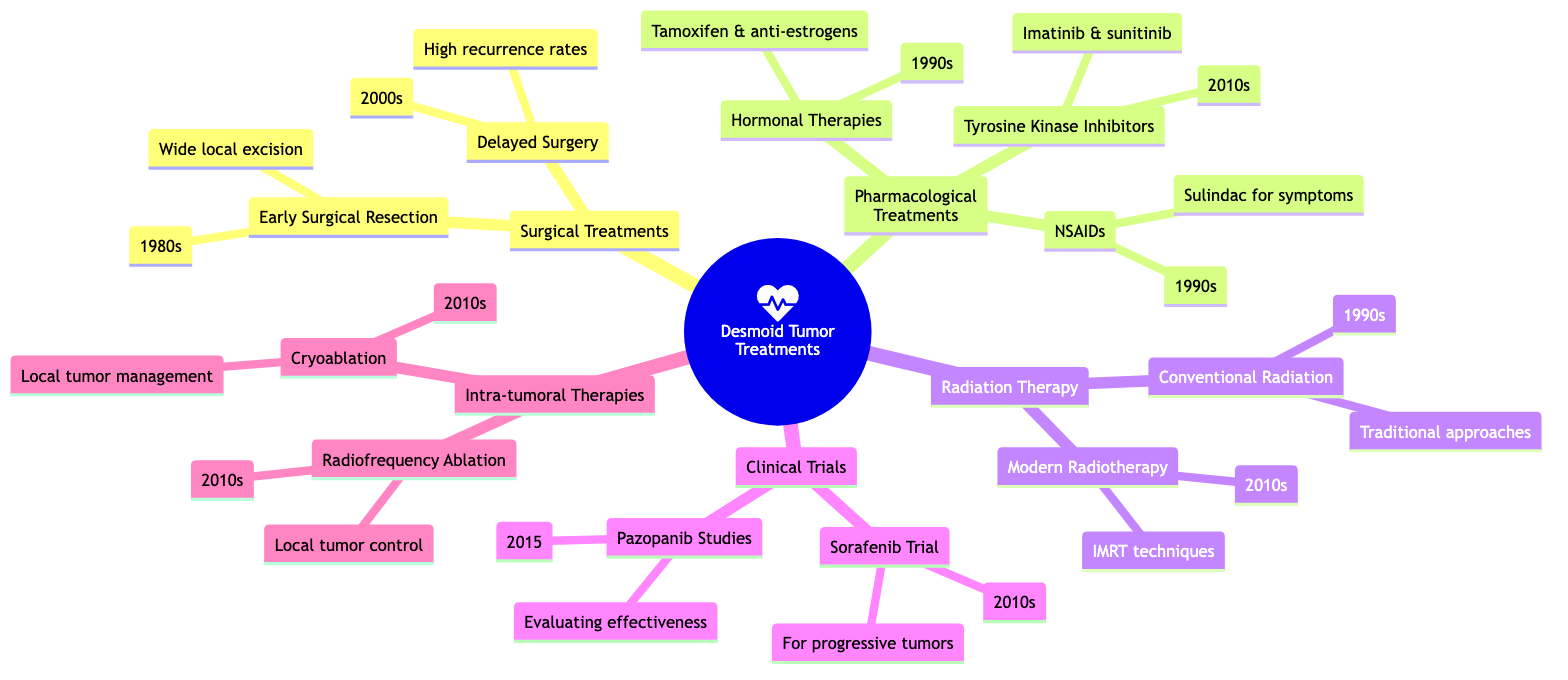What decade did Early Surgical Resection begin? The diagram indicates that Early Surgical Resection started in the 1980s, which is explicitly mentioned next to that node.
Answer: 1980s How many types of Pharmacological Treatments are listed? The diagram shows three distinct types of Pharmacological Treatments: Nonsteroidal Anti-inflammatory Drugs (NSAIDs), Hormonal Therapies, and Tyrosine Kinase Inhibitors. Counting these gives a total of three.
Answer: 3 What is the primary focus of the Sorafenib Trial? The description next to the Sorafenib Trial states it was focused on showing promise for progressive desmoid tumors, which gives the main aim of the clinical trial.
Answer: Progressive desmoid tumors Which treatment introduced in the 1990s focuses on symptoms? Checking the subcategories under Pharmacological Treatments, Nonsteroidal Anti-inflammatory Drugs (NSAIDs) specifically mention the use of sulindac to manage symptoms, directly indicating its primary focus.
Answer: NSAIDs What type of therapy was introduced in the 2010s that includes intensity-modulated radiation therapy? The diagram shows Modern Radiotherapy Techniques as a child of Radiation Therapy, specifically indicating that IMRT is part of its modern approach introduced in the 2010s.
Answer: Modern Radiotherapy Techniques Which treatments were developed in the 2010s? By reviewing the diagram, both Tyrosine Kinase Inhibitors and Intra-tumoral Therapies (Cryoablation and Radiofrequency Ablation) lists treatments introduced in the 2010s, making it necessary to identify all relevant therapies during this decade.
Answer: Tyrosine Kinase Inhibitors, Cryoablation, Radiofrequency Ablation How does Delayed Surgery relate to earlier surgical approaches? The relationship is outlined in the diagram, showing that Delayed Surgery was influenced by the earlier approach of Early Surgical Resection due to high rates of recurrence observed, indicating a shift in practice based on prior experiences.
Answer: Shift in approach due to recurrence rates What type of study evaluated pazopanib effectiveness? The description for Pazopanib Clinical Studies specifies that it aimed at evaluating the effectiveness of pazopanib in managing desmoid tumors, clearly defining type as a study.
Answer: Clinical Studies 